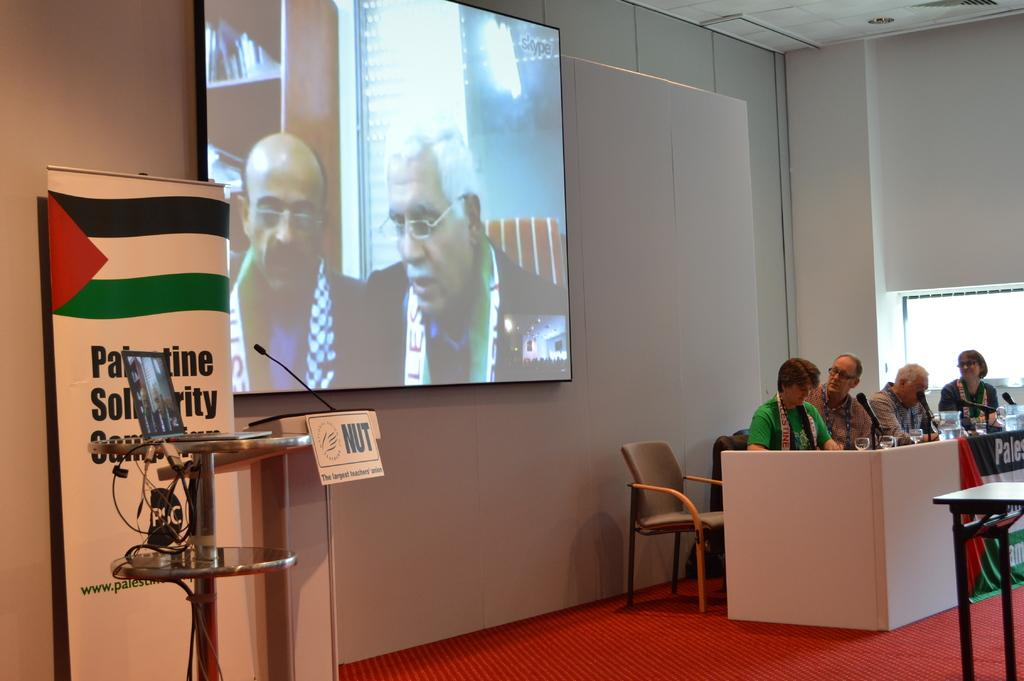What is the person in the image doing? The person is sitting on a chair. What is in front of the chair? There is a table in front of the chair. What is on the table? There is a microphone on the table, and there are other objects on the table as well. What can be seen at the back of the scene? There is a projector screen at the back of the scene. What type of metal is the person's brother using to print a document in the image? There is no person's brother or printing activity present in the image. 